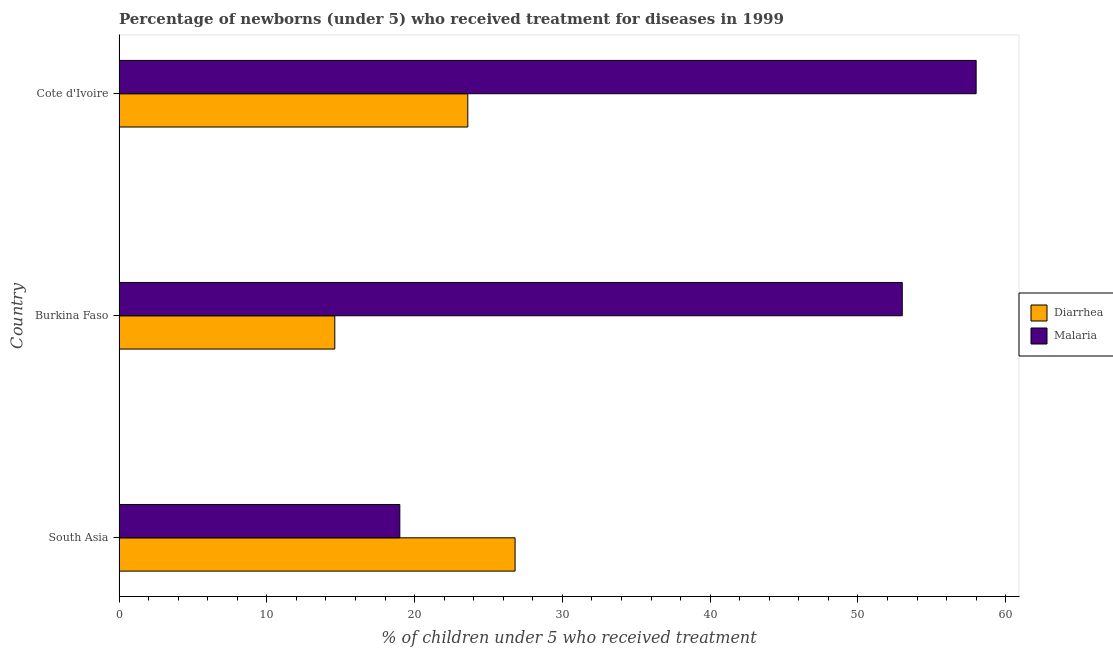Are the number of bars per tick equal to the number of legend labels?
Your response must be concise. Yes. How many bars are there on the 1st tick from the top?
Your answer should be very brief. 2. What is the label of the 2nd group of bars from the top?
Provide a succinct answer. Burkina Faso. Across all countries, what is the maximum percentage of children who received treatment for diarrhoea?
Your response must be concise. 26.8. Across all countries, what is the minimum percentage of children who received treatment for malaria?
Keep it short and to the point. 19. In which country was the percentage of children who received treatment for diarrhoea minimum?
Provide a short and direct response. Burkina Faso. What is the difference between the percentage of children who received treatment for diarrhoea in South Asia and the percentage of children who received treatment for malaria in Cote d'Ivoire?
Provide a succinct answer. -31.2. What is the average percentage of children who received treatment for malaria per country?
Your response must be concise. 43.33. What is the difference between the percentage of children who received treatment for malaria and percentage of children who received treatment for diarrhoea in Burkina Faso?
Your answer should be very brief. 38.4. What is the ratio of the percentage of children who received treatment for diarrhoea in Burkina Faso to that in South Asia?
Give a very brief answer. 0.55. Is the percentage of children who received treatment for diarrhoea in Burkina Faso less than that in Cote d'Ivoire?
Ensure brevity in your answer.  Yes. What is the difference between the highest and the second highest percentage of children who received treatment for diarrhoea?
Provide a short and direct response. 3.2. What is the difference between the highest and the lowest percentage of children who received treatment for malaria?
Offer a very short reply. 39. What does the 2nd bar from the top in Burkina Faso represents?
Make the answer very short. Diarrhea. What does the 1st bar from the bottom in Burkina Faso represents?
Offer a terse response. Diarrhea. Are all the bars in the graph horizontal?
Your answer should be compact. Yes. Does the graph contain grids?
Give a very brief answer. No. How many legend labels are there?
Your answer should be very brief. 2. What is the title of the graph?
Provide a short and direct response. Percentage of newborns (under 5) who received treatment for diseases in 1999. What is the label or title of the X-axis?
Offer a terse response. % of children under 5 who received treatment. What is the % of children under 5 who received treatment of Diarrhea in South Asia?
Provide a succinct answer. 26.8. What is the % of children under 5 who received treatment of Malaria in South Asia?
Provide a succinct answer. 19. What is the % of children under 5 who received treatment in Malaria in Burkina Faso?
Make the answer very short. 53. What is the % of children under 5 who received treatment of Diarrhea in Cote d'Ivoire?
Keep it short and to the point. 23.6. What is the % of children under 5 who received treatment of Malaria in Cote d'Ivoire?
Keep it short and to the point. 58. Across all countries, what is the maximum % of children under 5 who received treatment of Diarrhea?
Give a very brief answer. 26.8. Across all countries, what is the maximum % of children under 5 who received treatment of Malaria?
Offer a terse response. 58. Across all countries, what is the minimum % of children under 5 who received treatment in Diarrhea?
Your answer should be very brief. 14.6. Across all countries, what is the minimum % of children under 5 who received treatment of Malaria?
Your answer should be compact. 19. What is the total % of children under 5 who received treatment of Malaria in the graph?
Your response must be concise. 130. What is the difference between the % of children under 5 who received treatment of Diarrhea in South Asia and that in Burkina Faso?
Offer a very short reply. 12.2. What is the difference between the % of children under 5 who received treatment of Malaria in South Asia and that in Burkina Faso?
Offer a terse response. -34. What is the difference between the % of children under 5 who received treatment of Diarrhea in South Asia and that in Cote d'Ivoire?
Your answer should be very brief. 3.2. What is the difference between the % of children under 5 who received treatment in Malaria in South Asia and that in Cote d'Ivoire?
Keep it short and to the point. -39. What is the difference between the % of children under 5 who received treatment of Malaria in Burkina Faso and that in Cote d'Ivoire?
Your answer should be very brief. -5. What is the difference between the % of children under 5 who received treatment in Diarrhea in South Asia and the % of children under 5 who received treatment in Malaria in Burkina Faso?
Ensure brevity in your answer.  -26.2. What is the difference between the % of children under 5 who received treatment in Diarrhea in South Asia and the % of children under 5 who received treatment in Malaria in Cote d'Ivoire?
Your answer should be very brief. -31.2. What is the difference between the % of children under 5 who received treatment of Diarrhea in Burkina Faso and the % of children under 5 who received treatment of Malaria in Cote d'Ivoire?
Provide a succinct answer. -43.4. What is the average % of children under 5 who received treatment in Diarrhea per country?
Keep it short and to the point. 21.67. What is the average % of children under 5 who received treatment in Malaria per country?
Ensure brevity in your answer.  43.33. What is the difference between the % of children under 5 who received treatment in Diarrhea and % of children under 5 who received treatment in Malaria in Burkina Faso?
Keep it short and to the point. -38.4. What is the difference between the % of children under 5 who received treatment in Diarrhea and % of children under 5 who received treatment in Malaria in Cote d'Ivoire?
Keep it short and to the point. -34.4. What is the ratio of the % of children under 5 who received treatment in Diarrhea in South Asia to that in Burkina Faso?
Offer a very short reply. 1.84. What is the ratio of the % of children under 5 who received treatment of Malaria in South Asia to that in Burkina Faso?
Keep it short and to the point. 0.36. What is the ratio of the % of children under 5 who received treatment of Diarrhea in South Asia to that in Cote d'Ivoire?
Offer a very short reply. 1.14. What is the ratio of the % of children under 5 who received treatment in Malaria in South Asia to that in Cote d'Ivoire?
Provide a short and direct response. 0.33. What is the ratio of the % of children under 5 who received treatment of Diarrhea in Burkina Faso to that in Cote d'Ivoire?
Make the answer very short. 0.62. What is the ratio of the % of children under 5 who received treatment of Malaria in Burkina Faso to that in Cote d'Ivoire?
Make the answer very short. 0.91. What is the difference between the highest and the second highest % of children under 5 who received treatment of Diarrhea?
Provide a short and direct response. 3.2. What is the difference between the highest and the second highest % of children under 5 who received treatment of Malaria?
Keep it short and to the point. 5. 